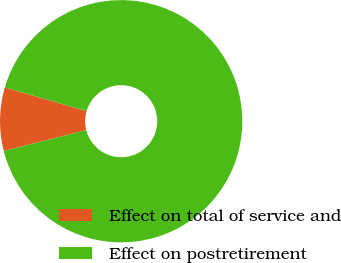<chart> <loc_0><loc_0><loc_500><loc_500><pie_chart><fcel>Effect on total of service and<fcel>Effect on postretirement<nl><fcel>8.45%<fcel>91.55%<nl></chart> 